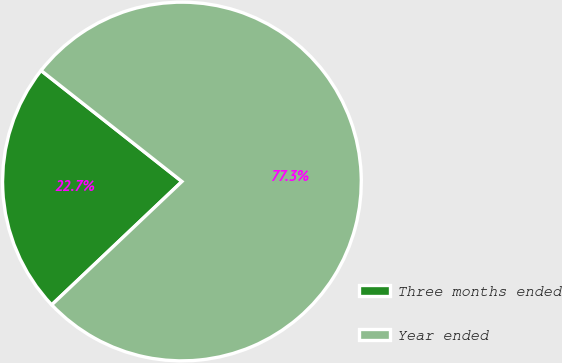<chart> <loc_0><loc_0><loc_500><loc_500><pie_chart><fcel>Three months ended<fcel>Year ended<nl><fcel>22.69%<fcel>77.31%<nl></chart> 